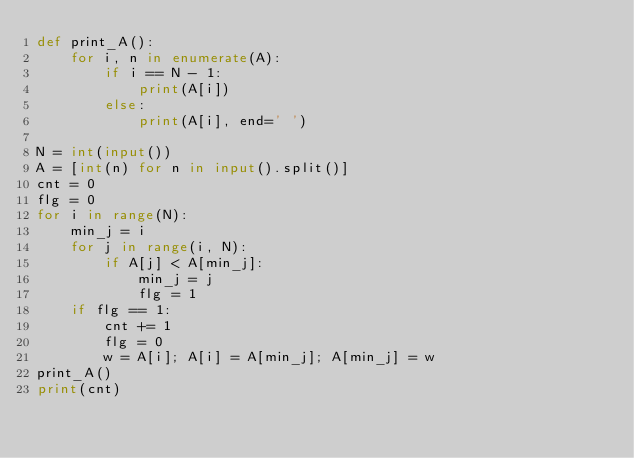Convert code to text. <code><loc_0><loc_0><loc_500><loc_500><_Python_>def print_A():
    for i, n in enumerate(A):
        if i == N - 1:
            print(A[i])
        else:
            print(A[i], end=' ')

N = int(input())
A = [int(n) for n in input().split()]
cnt = 0
flg = 0
for i in range(N):
    min_j = i
    for j in range(i, N):
        if A[j] < A[min_j]:
            min_j = j
            flg = 1
    if flg == 1:
        cnt += 1
        flg = 0
        w = A[i]; A[i] = A[min_j]; A[min_j] = w
print_A()
print(cnt)

</code> 